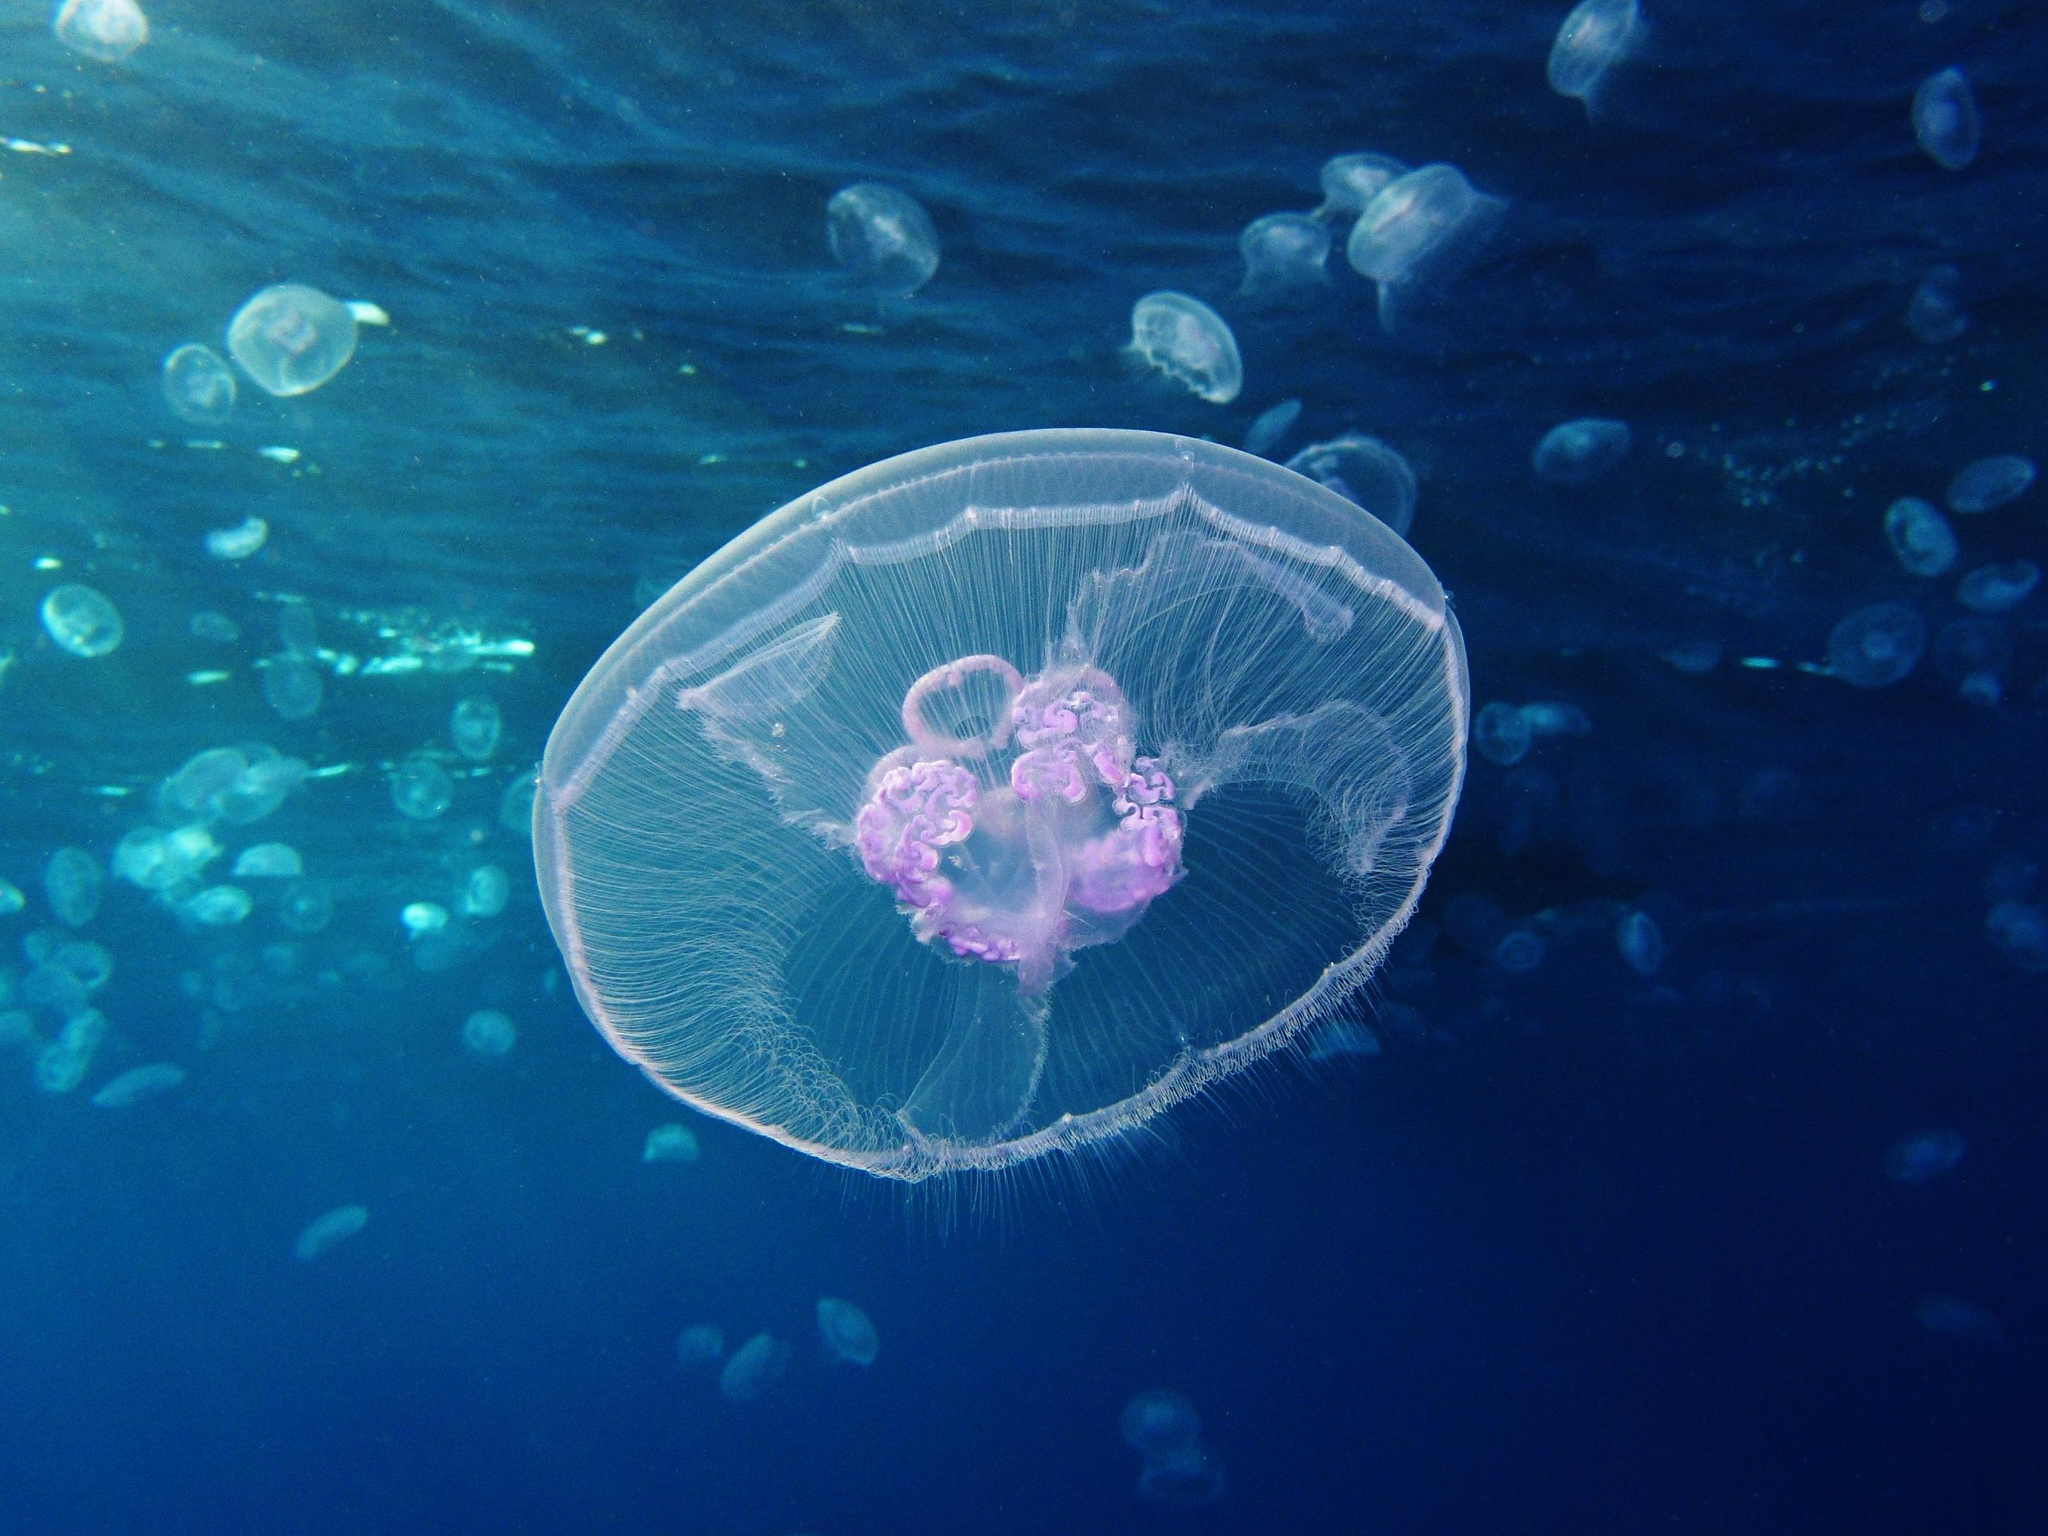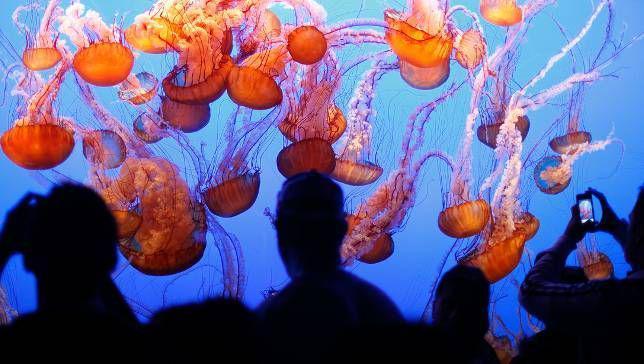The first image is the image on the left, the second image is the image on the right. Analyze the images presented: Is the assertion "An image shows at least a dozen vivid orange-red jellyfish." valid? Answer yes or no. Yes. 